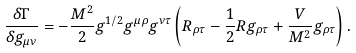Convert formula to latex. <formula><loc_0><loc_0><loc_500><loc_500>\frac { \delta \Gamma } { \delta g _ { \mu \nu } } = - \frac { M ^ { 2 } } { 2 } g ^ { 1 / 2 } g ^ { \mu \rho } g ^ { \nu \tau } \left ( R _ { \rho \tau } - \frac { 1 } { 2 } R g _ { \rho \tau } + \frac { V } { M ^ { 2 } } g _ { \rho \tau } \right ) .</formula> 